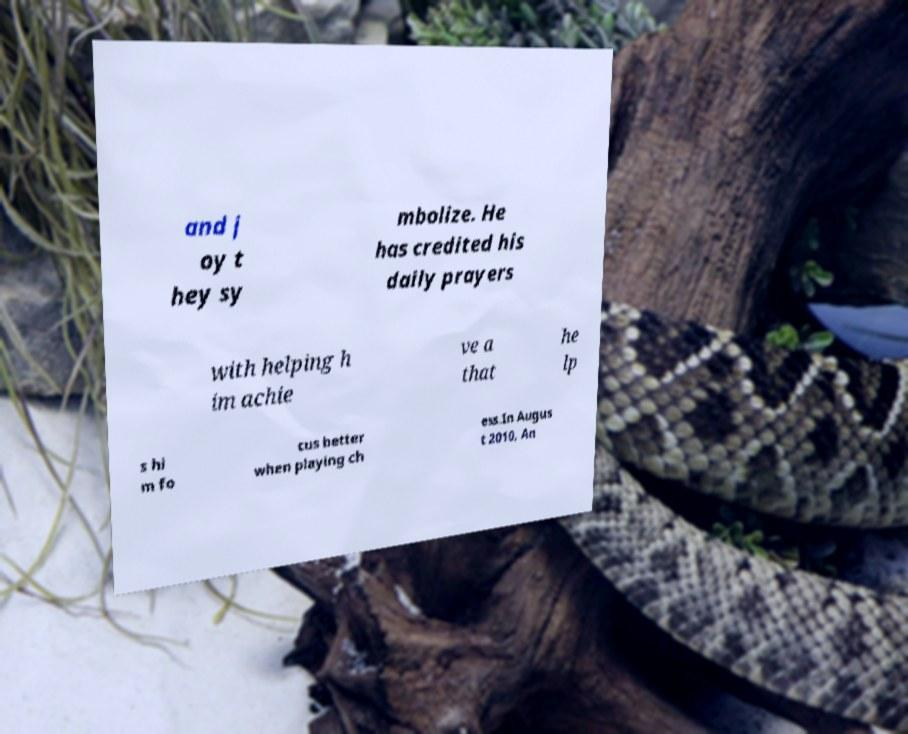I need the written content from this picture converted into text. Can you do that? and j oy t hey sy mbolize. He has credited his daily prayers with helping h im achie ve a that he lp s hi m fo cus better when playing ch ess.In Augus t 2010, An 